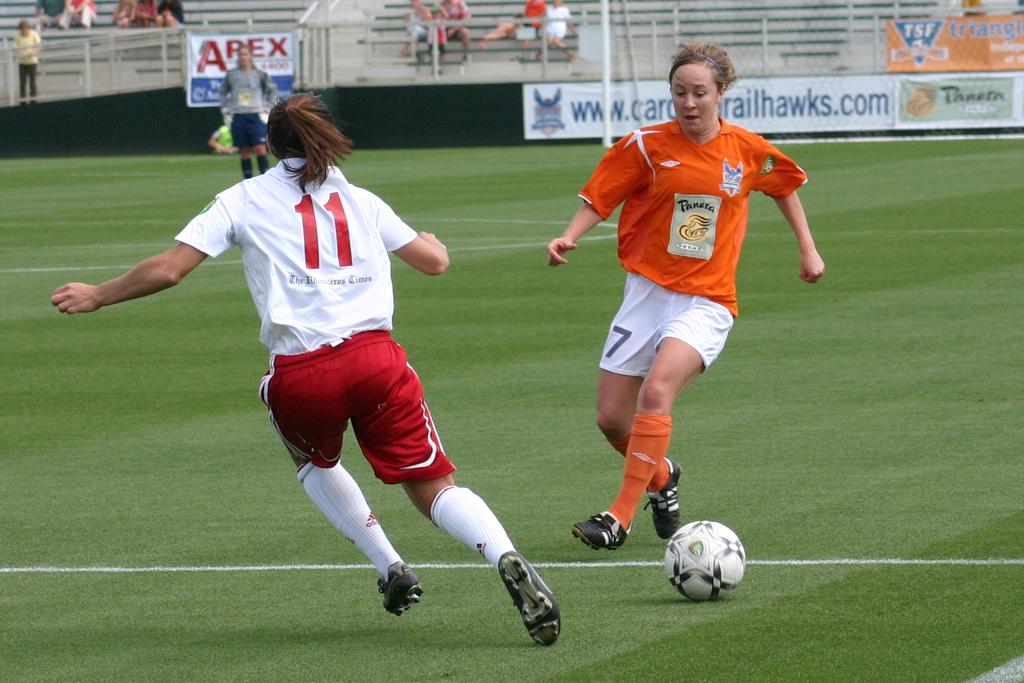What is the number on the white shorts?
Ensure brevity in your answer.  7. What number is on the back of the white jersey?
Your answer should be very brief. 11. 